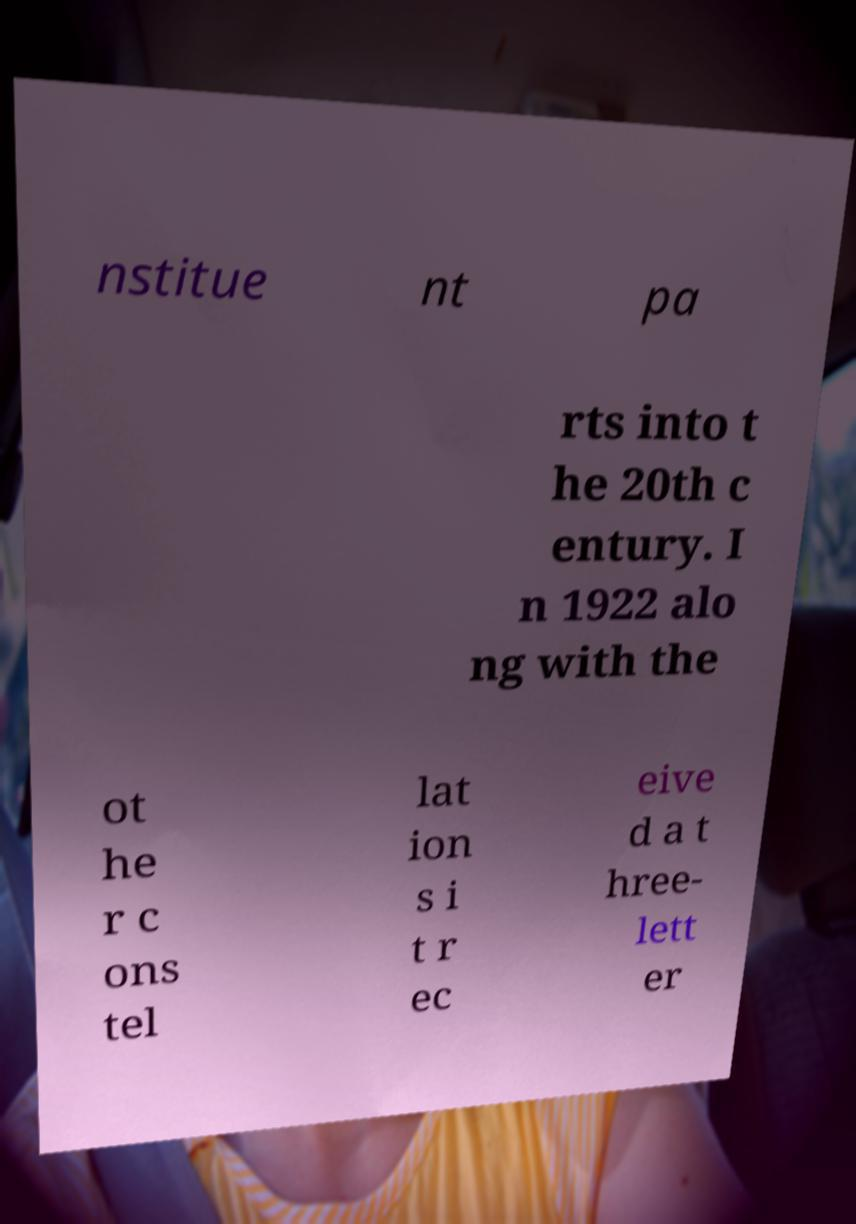Please read and relay the text visible in this image. What does it say? nstitue nt pa rts into t he 20th c entury. I n 1922 alo ng with the ot he r c ons tel lat ion s i t r ec eive d a t hree- lett er 